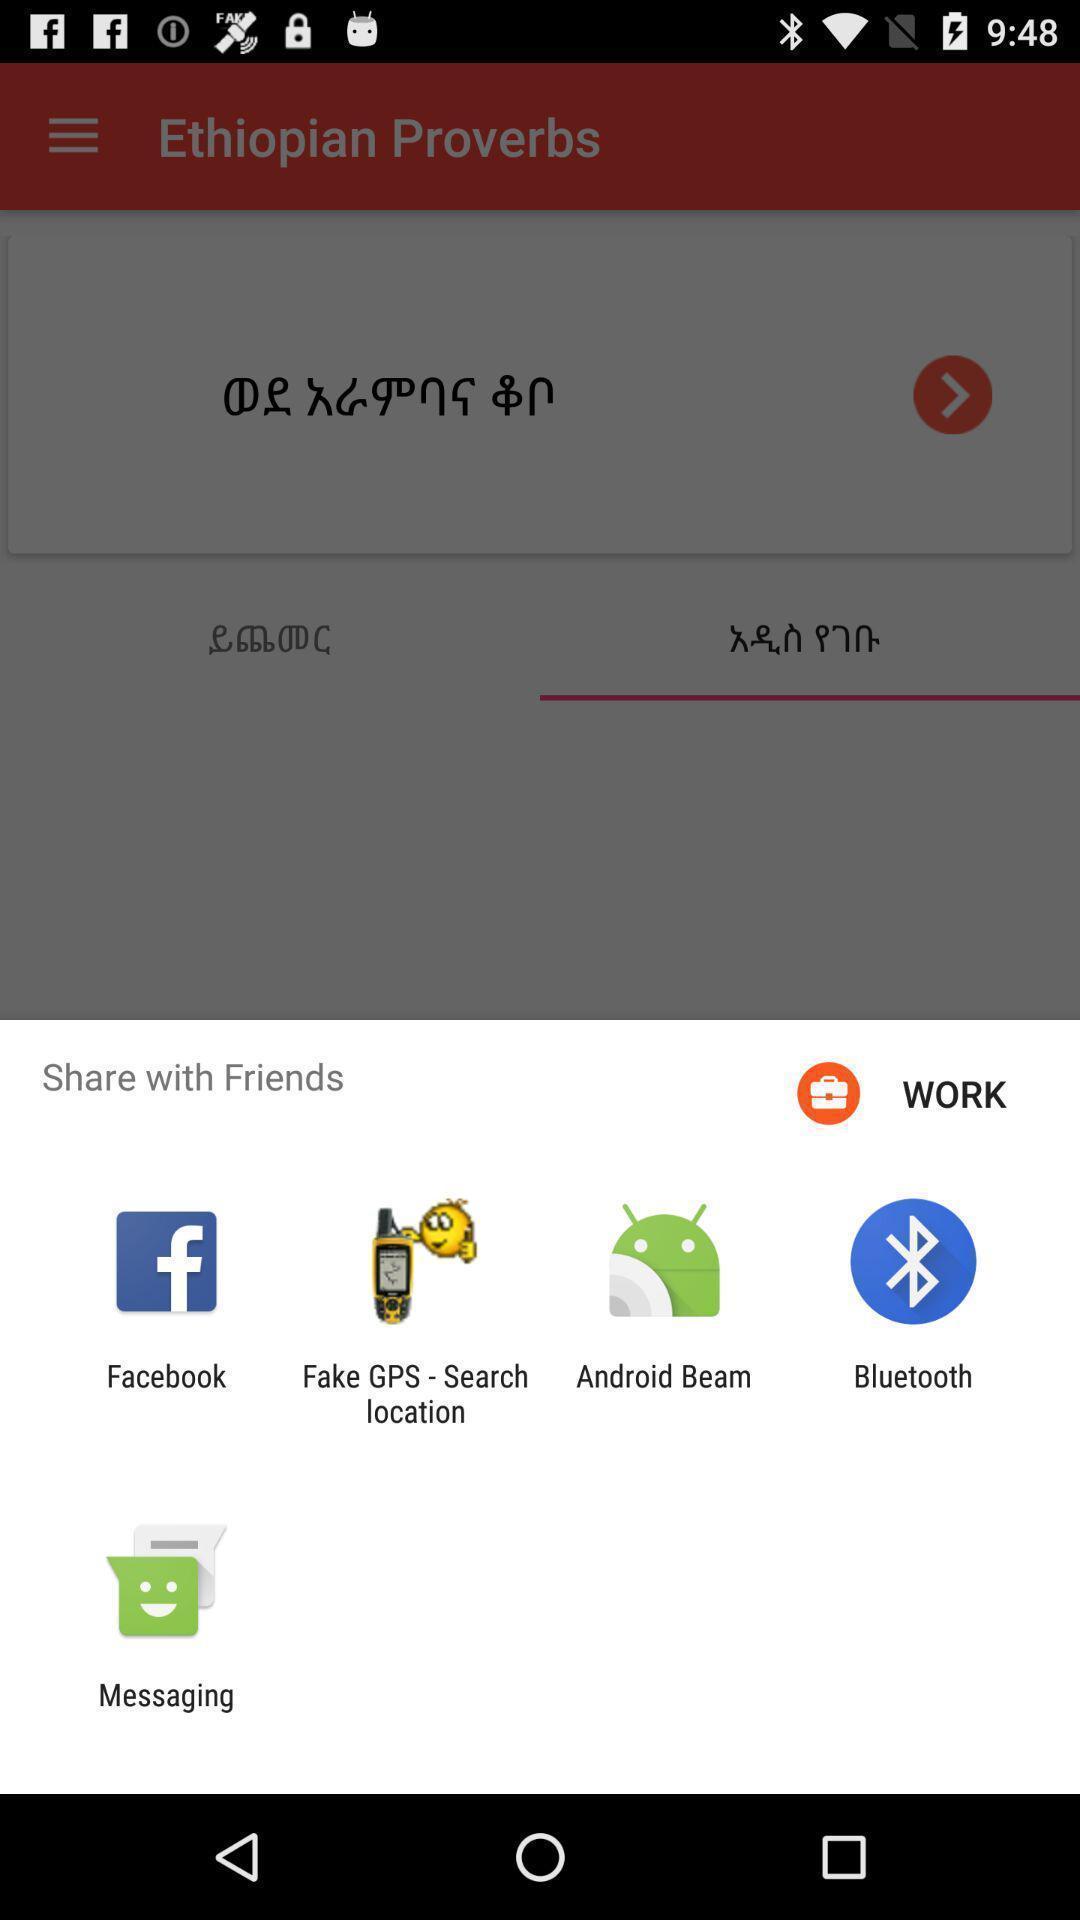Describe the content in this image. Sharing proverbs through different apps. 